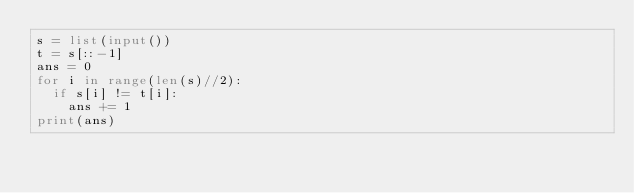Convert code to text. <code><loc_0><loc_0><loc_500><loc_500><_Python_>s = list(input())
t = s[::-1]
ans = 0
for i in range(len(s)//2):
  if s[i] != t[i]:
    ans += 1
print(ans)</code> 